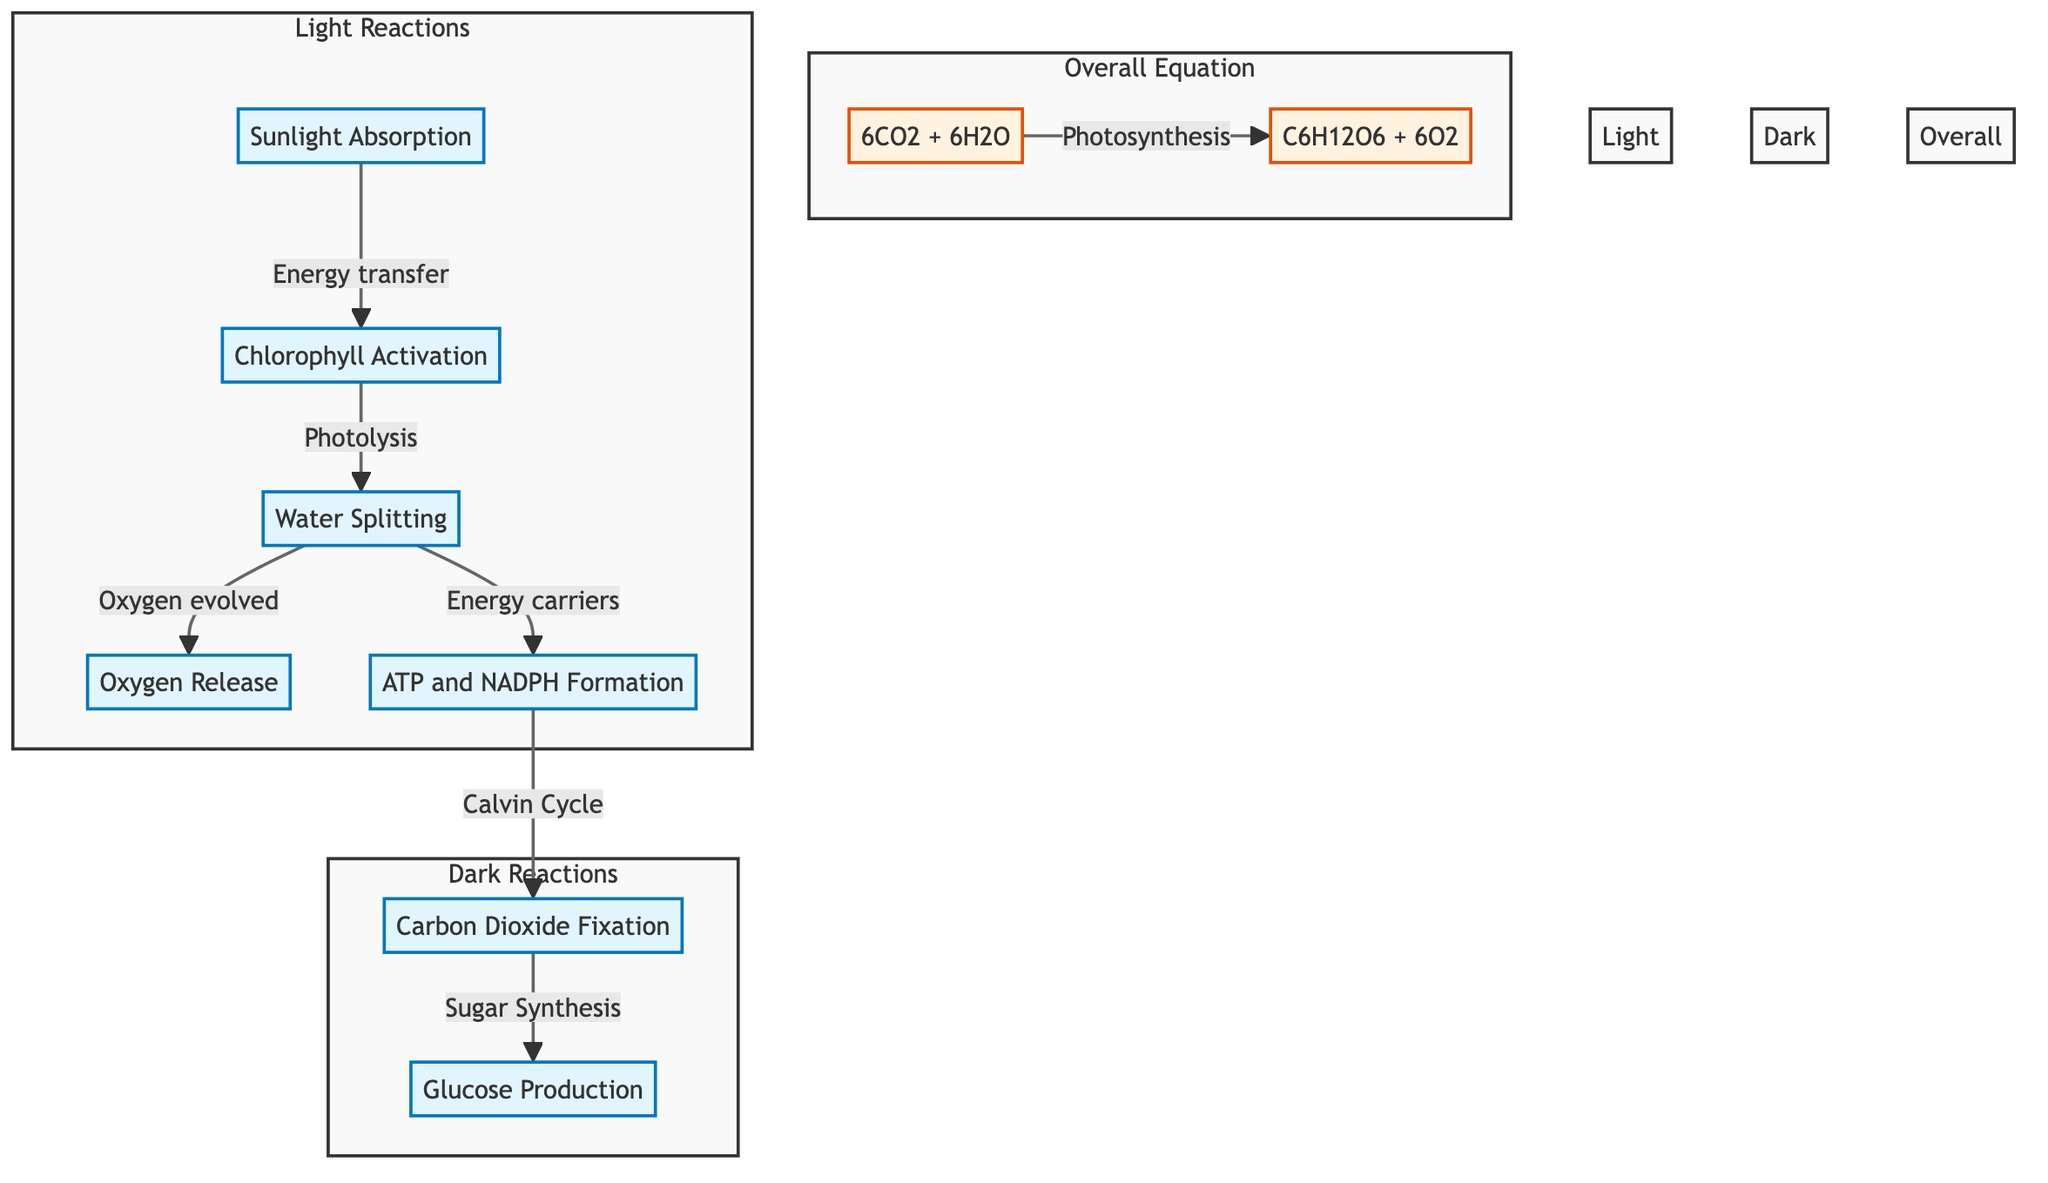What is the first step in the photosynthesis process? The diagram clearly indicates that the first step is "Sunlight Absorption." This is the initial action that initiates the photosynthesis process.
Answer: Sunlight Absorption How many stages are there in the flowchart? By counting the distinct steps in the process, including the Light Reactions and Dark Reactions, we find a total of 7 distinct steps.
Answer: 7 What is produced alongside glucose in the overall equation? The overall equation indicates that oxygen is produced, alongside glucose, during the photosynthesis process.
Answer: 6O2 Which process leads to ATP and NADPH formation? The diagram shows that "Water Splitting" leads to the formation of ATP and NADPH through the energy carriers generated during this stage.
Answer: Water Splitting What are the two main reactions described in the diagram? The diagram differentiates between Light Reactions and Dark Reactions, which are both essential stages of the photosynthesis process.
Answer: Light Reactions and Dark Reactions What does the equation "6CO2 + 6H2O" represent? In the diagram, this equation illustrates the reactants involved in the overall photosynthesis process before producing glucose and oxygen.
Answer: Reactants Which component is responsible for chlorophyll activation? The diagram states that "Sunlight Absorption" is responsible for the activation of chlorophyll, which is essential for the photosynthesis process.
Answer: Sunlight Absorption What energy carriers are formed during the Light Reactions? The diagram specifies that during the Light Reactions, ATP and NADPH are formed through the process following water splitting.
Answer: ATP and NADPH What is the final product of the photosynthesis flowchart? The flowchart concludes with glucose production as the final product, derived from the prior stages involving carbon dioxide fixation and sugar synthesis.
Answer: Glucose Production 